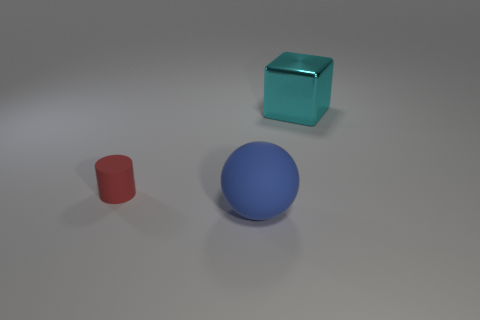Does the matte thing to the left of the blue rubber object have the same shape as the thing that is behind the small thing?
Offer a very short reply. No. There is a blue ball that is the same size as the metallic cube; what is its material?
Ensure brevity in your answer.  Rubber. Is the object that is in front of the tiny matte thing made of the same material as the large thing behind the matte cylinder?
Your response must be concise. No. There is a object that is the same size as the rubber sphere; what is its shape?
Make the answer very short. Cube. How many other objects are the same color as the large rubber ball?
Offer a very short reply. 0. What is the color of the large thing behind the blue rubber thing?
Offer a very short reply. Cyan. What number of other things are the same material as the big cyan block?
Keep it short and to the point. 0. Is the number of red cylinders behind the red thing greater than the number of big balls that are behind the blue object?
Offer a very short reply. No. There is a large metal block; how many cubes are behind it?
Your answer should be very brief. 0. Is the block made of the same material as the thing left of the blue rubber thing?
Make the answer very short. No. 